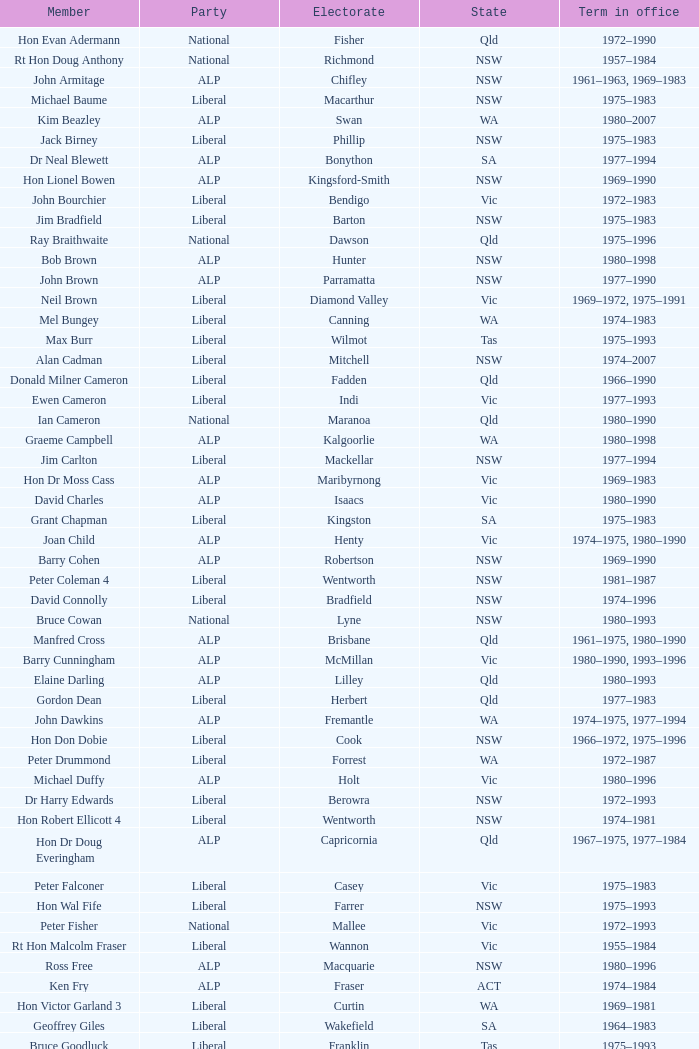Which faction consisted of a person from the vic territory and an electoral division known as wannon? Liberal. 